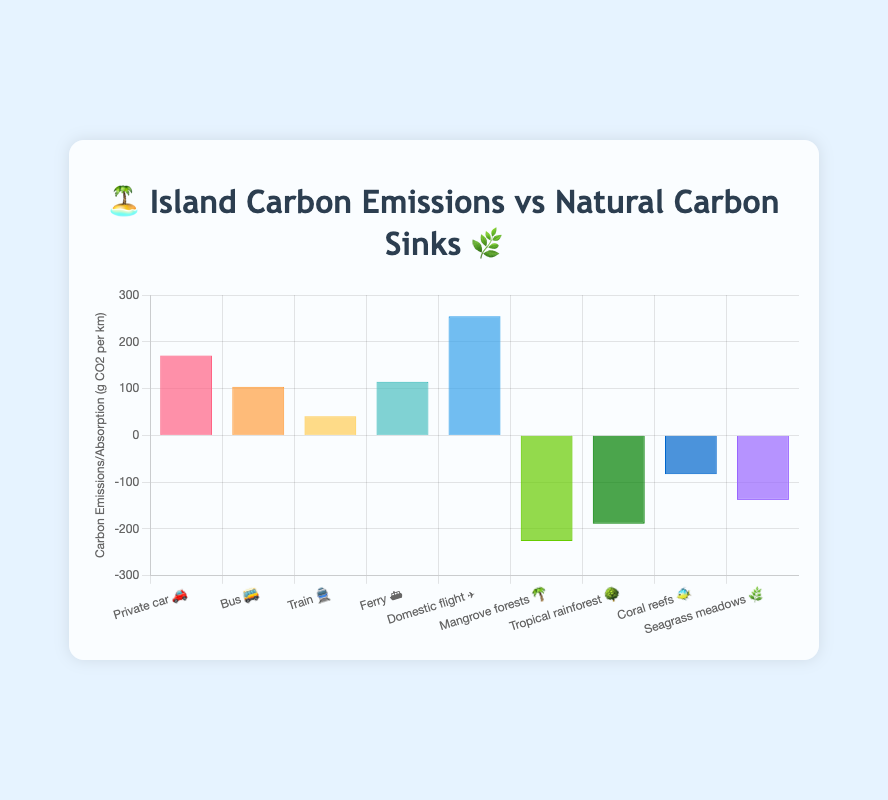What is the title of the chart? The title is located at the top of the chart.
Answer: Island Carbon Emissions vs Natural Carbon Sinks Which transportation mode has the highest carbon emissions per passenger km? By looking at the bar heights and labels, we can identify that 'Domestic flight ✈️' has the highest emissions.
Answer: Domestic flight ✈️ Which natural carbon sink has the highest absorption? By looking at the height of the bars representing the carbon sinks, 'Mangrove forests 🌴' has the tallest bar for absorption.
Answer: Mangrove forests 🌴 What is the average carbon emission per passenger km across all transportation modes? To find the average, sum all the emissions (171 + 104 + 41 + 115 + 255) and divide by the number of modes (5). The sum is 686, and dividing by 5 gives an average of 137.2.
Answer: 137.2 What is the difference between the highest and the lowest carbon absorption values? To find this, subtract the lowest absorption value ('Coral reefs 🐠' at 83) from the highest absorption value ('Mangrove forests 🌴' at 226). The difference is 226 - 83 = 143.
Answer: 143 How do the carbon emissions of 'Ferry ⛴️' compare to the carbon absorption of 'Seagrass meadows 🌿'? The emissions for 'Ferry ⛴️' are 115 g CO2/km and the absorption for 'Seagrass meadows 🌿' is 138 g CO2/km. The 'Ferry ⛴️' emits less than the 'Seagrass meadows 🌿' absorbs.
Answer: Less Which transportation mode has lower carbon emissions per passenger km than 'Bus 🚌' but higher than 'Train 🚆'? Comparing the emissions, 'Ferry ⛴️' fits this condition with 115 g CO2/km, which is less than 'Bus 🚌' at 104 g CO2/km and higher than 'Train 🚆' at 41 g CO2/km.
Answer: Ferry ⛴️ Which category, emissions from transport modes or absorption by natural sinks, has more bars shown? There are 5 bars shown for emissions and 4 for absorptions. This information is found by counting the number of bars in each category.
Answer: Emissions from transport How does the carbon absorption by 'Tropical rainforest 🌳' compare with the emissions from 'Bus 🚌'? The absorption by 'Tropical rainforest 🌳' is 189 g CO2/km, while the emissions from 'Bus 🚌' are 104 g CO2/km. 'Tropical rainforest 🌳' absorbs more than 'Bus 🚌' emits.
Answer: Absorbs more 